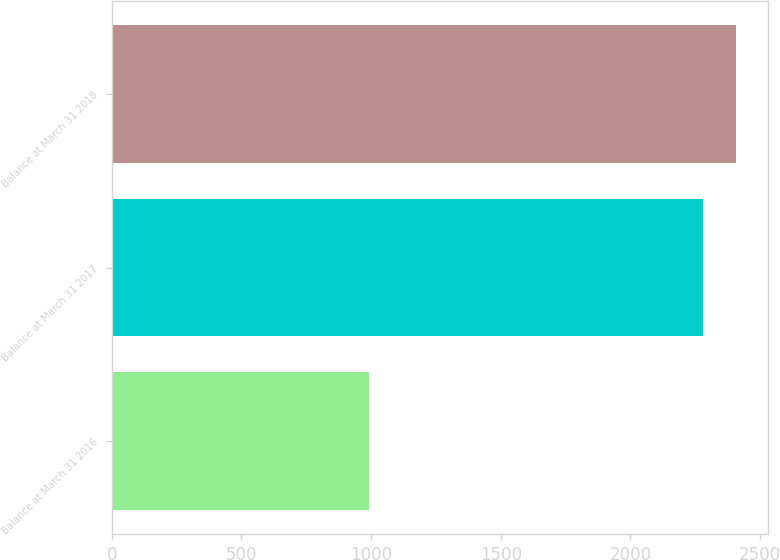Convert chart. <chart><loc_0><loc_0><loc_500><loc_500><bar_chart><fcel>Balance at March 31 2016<fcel>Balance at March 31 2017<fcel>Balance at March 31 2018<nl><fcel>993.5<fcel>2279.8<fcel>2408.43<nl></chart> 